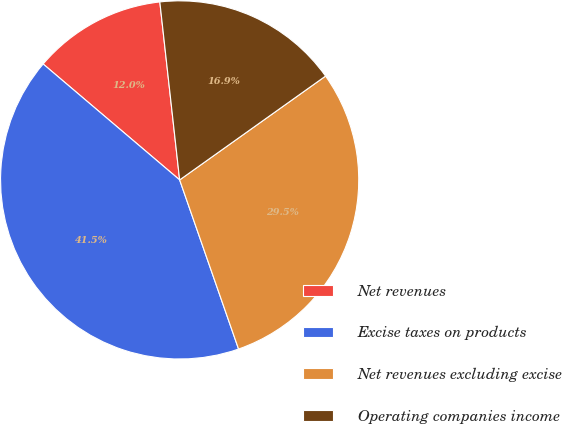Convert chart to OTSL. <chart><loc_0><loc_0><loc_500><loc_500><pie_chart><fcel>Net revenues<fcel>Excise taxes on products<fcel>Net revenues excluding excise<fcel>Operating companies income<nl><fcel>12.03%<fcel>41.54%<fcel>29.51%<fcel>16.92%<nl></chart> 